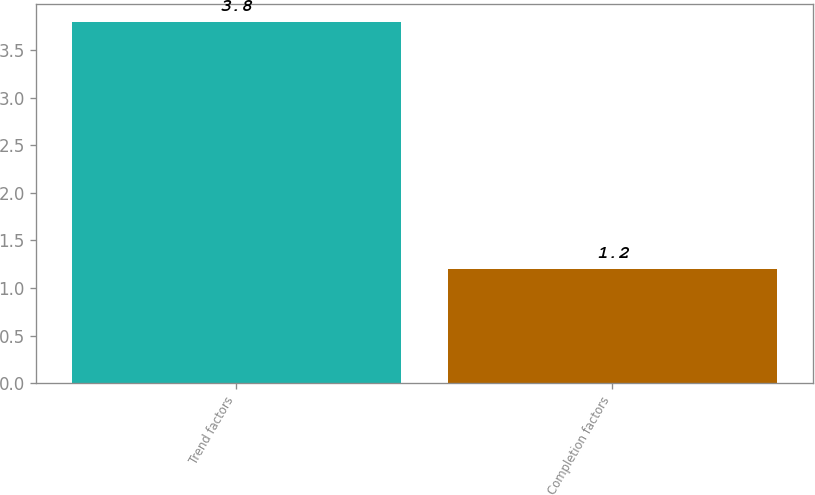Convert chart to OTSL. <chart><loc_0><loc_0><loc_500><loc_500><bar_chart><fcel>Trend factors<fcel>Completion factors<nl><fcel>3.8<fcel>1.2<nl></chart> 